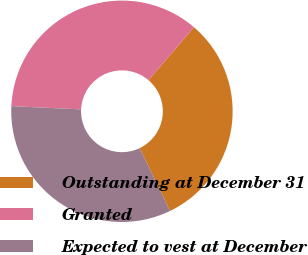Convert chart. <chart><loc_0><loc_0><loc_500><loc_500><pie_chart><fcel>Outstanding at December 31<fcel>Granted<fcel>Expected to vest at December<nl><fcel>31.58%<fcel>35.53%<fcel>32.89%<nl></chart> 